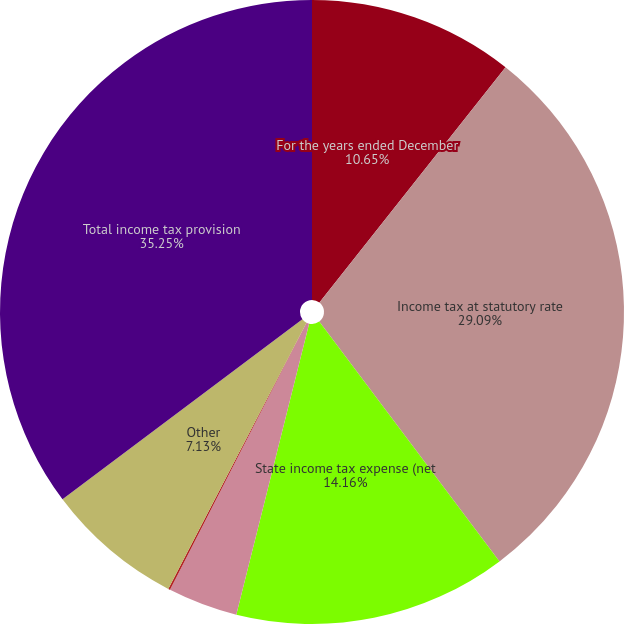Convert chart. <chart><loc_0><loc_0><loc_500><loc_500><pie_chart><fcel>For the years ended December<fcel>Income tax at statutory rate<fcel>State income tax expense (net<fcel>Foreign tax expense/(benefit)<fcel>Foreign tax<fcel>Other<fcel>Total income tax provision<nl><fcel>10.65%<fcel>29.09%<fcel>14.16%<fcel>3.62%<fcel>0.1%<fcel>7.13%<fcel>35.25%<nl></chart> 